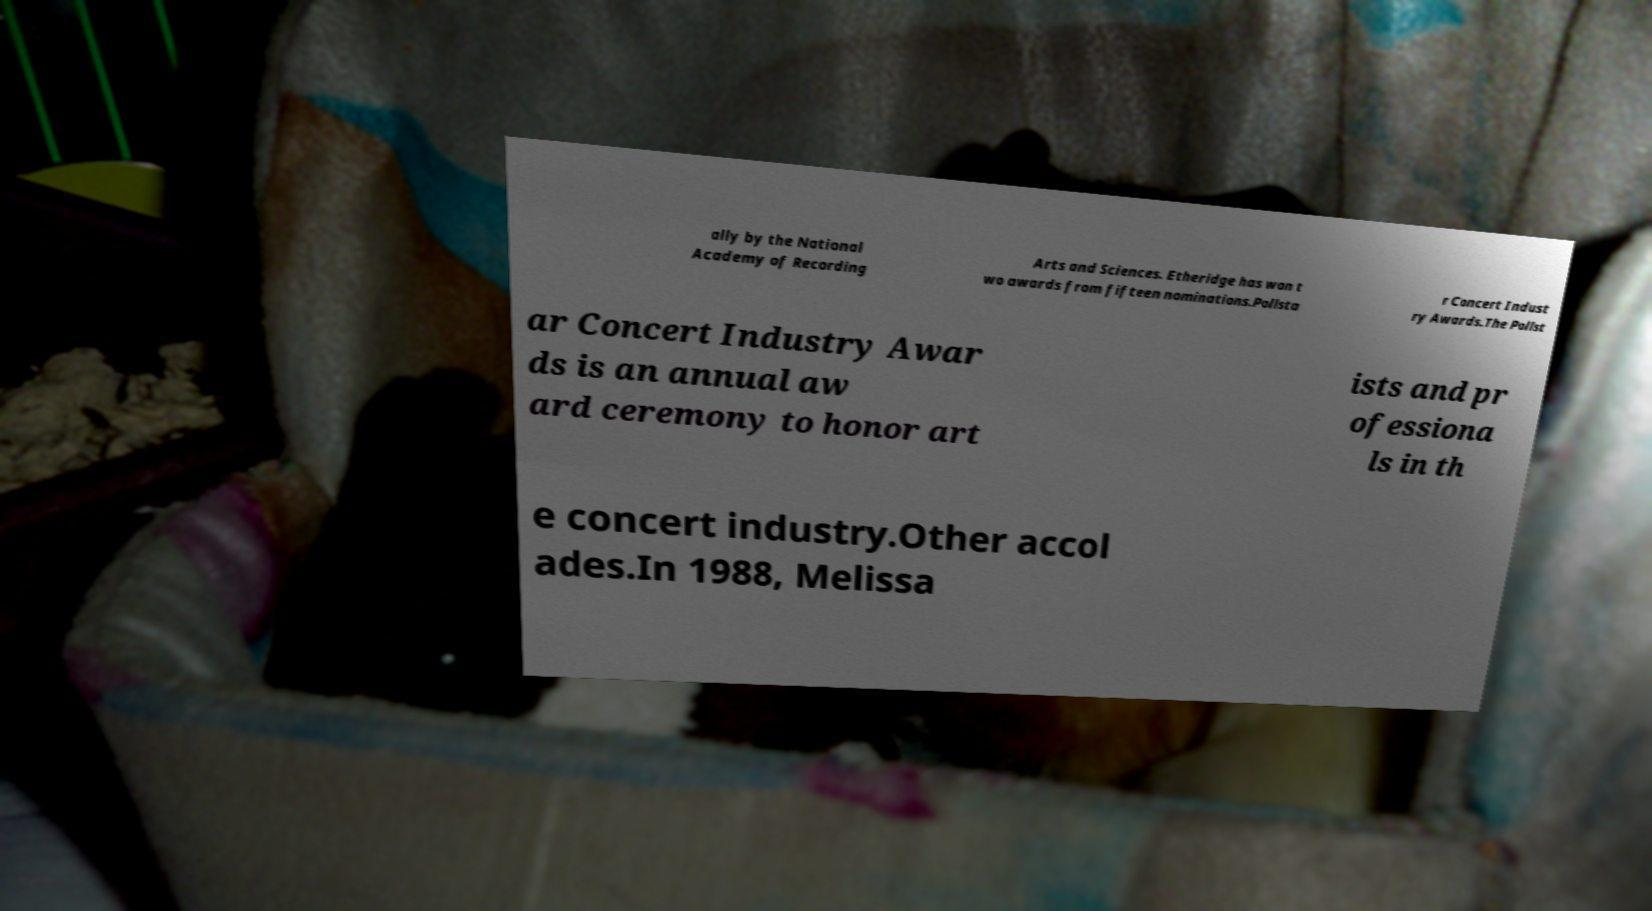Can you read and provide the text displayed in the image?This photo seems to have some interesting text. Can you extract and type it out for me? ally by the National Academy of Recording Arts and Sciences. Etheridge has won t wo awards from fifteen nominations.Pollsta r Concert Indust ry Awards.The Pollst ar Concert Industry Awar ds is an annual aw ard ceremony to honor art ists and pr ofessiona ls in th e concert industry.Other accol ades.In 1988, Melissa 